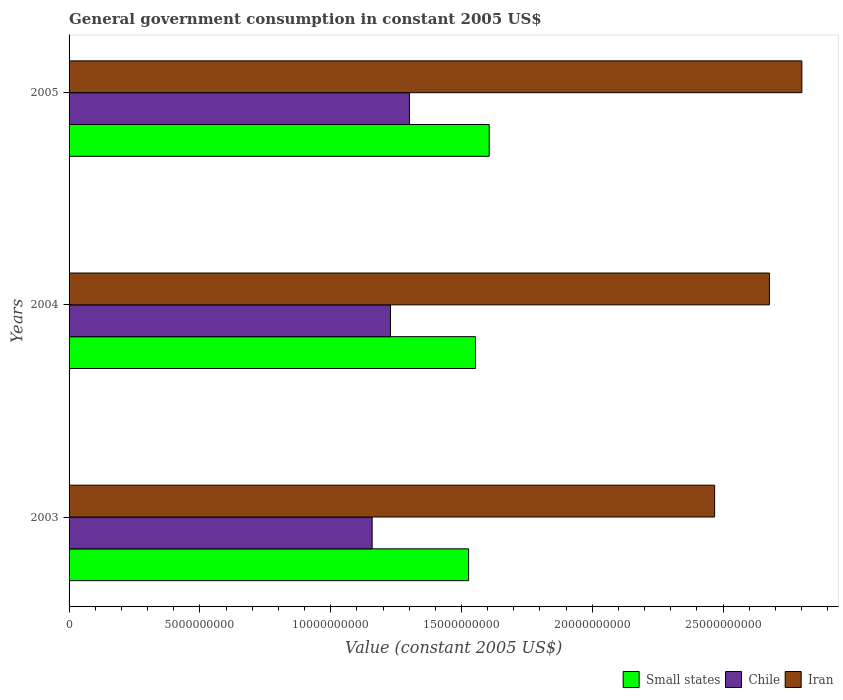How many different coloured bars are there?
Ensure brevity in your answer.  3. How many groups of bars are there?
Your answer should be very brief. 3. Are the number of bars per tick equal to the number of legend labels?
Provide a short and direct response. Yes. What is the label of the 2nd group of bars from the top?
Provide a short and direct response. 2004. In how many cases, is the number of bars for a given year not equal to the number of legend labels?
Your answer should be very brief. 0. What is the government conusmption in Iran in 2005?
Offer a very short reply. 2.80e+1. Across all years, what is the maximum government conusmption in Small states?
Your answer should be very brief. 1.61e+1. Across all years, what is the minimum government conusmption in Small states?
Your answer should be compact. 1.53e+1. In which year was the government conusmption in Iran maximum?
Ensure brevity in your answer.  2005. In which year was the government conusmption in Iran minimum?
Make the answer very short. 2003. What is the total government conusmption in Chile in the graph?
Provide a succinct answer. 3.69e+1. What is the difference between the government conusmption in Iran in 2004 and that in 2005?
Keep it short and to the point. -1.24e+09. What is the difference between the government conusmption in Chile in 2004 and the government conusmption in Iran in 2005?
Make the answer very short. -1.57e+1. What is the average government conusmption in Chile per year?
Ensure brevity in your answer.  1.23e+1. In the year 2005, what is the difference between the government conusmption in Iran and government conusmption in Small states?
Your answer should be very brief. 1.20e+1. In how many years, is the government conusmption in Iran greater than 3000000000 US$?
Offer a very short reply. 3. What is the ratio of the government conusmption in Chile in 2004 to that in 2005?
Your answer should be very brief. 0.94. What is the difference between the highest and the second highest government conusmption in Small states?
Your answer should be compact. 5.24e+08. What is the difference between the highest and the lowest government conusmption in Iran?
Keep it short and to the point. 3.33e+09. In how many years, is the government conusmption in Chile greater than the average government conusmption in Chile taken over all years?
Your answer should be compact. 1. Is the sum of the government conusmption in Iran in 2003 and 2005 greater than the maximum government conusmption in Chile across all years?
Your answer should be very brief. Yes. What does the 3rd bar from the top in 2005 represents?
Make the answer very short. Small states. What does the 2nd bar from the bottom in 2005 represents?
Your answer should be compact. Chile. How many bars are there?
Give a very brief answer. 9. How many years are there in the graph?
Provide a succinct answer. 3. Does the graph contain grids?
Provide a succinct answer. No. How are the legend labels stacked?
Provide a short and direct response. Horizontal. What is the title of the graph?
Make the answer very short. General government consumption in constant 2005 US$. What is the label or title of the X-axis?
Offer a terse response. Value (constant 2005 US$). What is the Value (constant 2005 US$) of Small states in 2003?
Give a very brief answer. 1.53e+1. What is the Value (constant 2005 US$) of Chile in 2003?
Your answer should be compact. 1.16e+1. What is the Value (constant 2005 US$) of Iran in 2003?
Provide a short and direct response. 2.47e+1. What is the Value (constant 2005 US$) of Small states in 2004?
Make the answer very short. 1.55e+1. What is the Value (constant 2005 US$) in Chile in 2004?
Provide a short and direct response. 1.23e+1. What is the Value (constant 2005 US$) in Iran in 2004?
Your response must be concise. 2.68e+1. What is the Value (constant 2005 US$) in Small states in 2005?
Ensure brevity in your answer.  1.61e+1. What is the Value (constant 2005 US$) of Chile in 2005?
Give a very brief answer. 1.30e+1. What is the Value (constant 2005 US$) in Iran in 2005?
Offer a terse response. 2.80e+1. Across all years, what is the maximum Value (constant 2005 US$) in Small states?
Keep it short and to the point. 1.61e+1. Across all years, what is the maximum Value (constant 2005 US$) in Chile?
Provide a succinct answer. 1.30e+1. Across all years, what is the maximum Value (constant 2005 US$) of Iran?
Keep it short and to the point. 2.80e+1. Across all years, what is the minimum Value (constant 2005 US$) of Small states?
Offer a terse response. 1.53e+1. Across all years, what is the minimum Value (constant 2005 US$) in Chile?
Keep it short and to the point. 1.16e+1. Across all years, what is the minimum Value (constant 2005 US$) of Iran?
Your answer should be very brief. 2.47e+1. What is the total Value (constant 2005 US$) in Small states in the graph?
Your answer should be compact. 4.69e+1. What is the total Value (constant 2005 US$) in Chile in the graph?
Offer a terse response. 3.69e+1. What is the total Value (constant 2005 US$) in Iran in the graph?
Your answer should be very brief. 7.95e+1. What is the difference between the Value (constant 2005 US$) of Small states in 2003 and that in 2004?
Your answer should be very brief. -2.64e+08. What is the difference between the Value (constant 2005 US$) in Chile in 2003 and that in 2004?
Offer a very short reply. -7.01e+08. What is the difference between the Value (constant 2005 US$) of Iran in 2003 and that in 2004?
Give a very brief answer. -2.09e+09. What is the difference between the Value (constant 2005 US$) in Small states in 2003 and that in 2005?
Offer a terse response. -7.88e+08. What is the difference between the Value (constant 2005 US$) of Chile in 2003 and that in 2005?
Your response must be concise. -1.43e+09. What is the difference between the Value (constant 2005 US$) in Iran in 2003 and that in 2005?
Offer a terse response. -3.33e+09. What is the difference between the Value (constant 2005 US$) in Small states in 2004 and that in 2005?
Offer a terse response. -5.24e+08. What is the difference between the Value (constant 2005 US$) of Chile in 2004 and that in 2005?
Your response must be concise. -7.25e+08. What is the difference between the Value (constant 2005 US$) of Iran in 2004 and that in 2005?
Make the answer very short. -1.24e+09. What is the difference between the Value (constant 2005 US$) of Small states in 2003 and the Value (constant 2005 US$) of Chile in 2004?
Provide a succinct answer. 2.99e+09. What is the difference between the Value (constant 2005 US$) of Small states in 2003 and the Value (constant 2005 US$) of Iran in 2004?
Make the answer very short. -1.15e+1. What is the difference between the Value (constant 2005 US$) of Chile in 2003 and the Value (constant 2005 US$) of Iran in 2004?
Your answer should be very brief. -1.52e+1. What is the difference between the Value (constant 2005 US$) in Small states in 2003 and the Value (constant 2005 US$) in Chile in 2005?
Offer a terse response. 2.26e+09. What is the difference between the Value (constant 2005 US$) in Small states in 2003 and the Value (constant 2005 US$) in Iran in 2005?
Your answer should be very brief. -1.27e+1. What is the difference between the Value (constant 2005 US$) in Chile in 2003 and the Value (constant 2005 US$) in Iran in 2005?
Give a very brief answer. -1.64e+1. What is the difference between the Value (constant 2005 US$) of Small states in 2004 and the Value (constant 2005 US$) of Chile in 2005?
Give a very brief answer. 2.52e+09. What is the difference between the Value (constant 2005 US$) in Small states in 2004 and the Value (constant 2005 US$) in Iran in 2005?
Offer a terse response. -1.25e+1. What is the difference between the Value (constant 2005 US$) of Chile in 2004 and the Value (constant 2005 US$) of Iran in 2005?
Ensure brevity in your answer.  -1.57e+1. What is the average Value (constant 2005 US$) of Small states per year?
Ensure brevity in your answer.  1.56e+1. What is the average Value (constant 2005 US$) in Chile per year?
Ensure brevity in your answer.  1.23e+1. What is the average Value (constant 2005 US$) in Iran per year?
Provide a succinct answer. 2.65e+1. In the year 2003, what is the difference between the Value (constant 2005 US$) in Small states and Value (constant 2005 US$) in Chile?
Offer a very short reply. 3.69e+09. In the year 2003, what is the difference between the Value (constant 2005 US$) of Small states and Value (constant 2005 US$) of Iran?
Keep it short and to the point. -9.40e+09. In the year 2003, what is the difference between the Value (constant 2005 US$) in Chile and Value (constant 2005 US$) in Iran?
Ensure brevity in your answer.  -1.31e+1. In the year 2004, what is the difference between the Value (constant 2005 US$) of Small states and Value (constant 2005 US$) of Chile?
Keep it short and to the point. 3.25e+09. In the year 2004, what is the difference between the Value (constant 2005 US$) of Small states and Value (constant 2005 US$) of Iran?
Keep it short and to the point. -1.12e+1. In the year 2004, what is the difference between the Value (constant 2005 US$) of Chile and Value (constant 2005 US$) of Iran?
Offer a very short reply. -1.45e+1. In the year 2005, what is the difference between the Value (constant 2005 US$) of Small states and Value (constant 2005 US$) of Chile?
Provide a short and direct response. 3.05e+09. In the year 2005, what is the difference between the Value (constant 2005 US$) of Small states and Value (constant 2005 US$) of Iran?
Your answer should be compact. -1.20e+1. In the year 2005, what is the difference between the Value (constant 2005 US$) of Chile and Value (constant 2005 US$) of Iran?
Offer a terse response. -1.50e+1. What is the ratio of the Value (constant 2005 US$) in Chile in 2003 to that in 2004?
Offer a very short reply. 0.94. What is the ratio of the Value (constant 2005 US$) in Iran in 2003 to that in 2004?
Offer a terse response. 0.92. What is the ratio of the Value (constant 2005 US$) of Small states in 2003 to that in 2005?
Your answer should be very brief. 0.95. What is the ratio of the Value (constant 2005 US$) in Chile in 2003 to that in 2005?
Ensure brevity in your answer.  0.89. What is the ratio of the Value (constant 2005 US$) of Iran in 2003 to that in 2005?
Give a very brief answer. 0.88. What is the ratio of the Value (constant 2005 US$) of Small states in 2004 to that in 2005?
Make the answer very short. 0.97. What is the ratio of the Value (constant 2005 US$) in Chile in 2004 to that in 2005?
Offer a terse response. 0.94. What is the ratio of the Value (constant 2005 US$) of Iran in 2004 to that in 2005?
Your response must be concise. 0.96. What is the difference between the highest and the second highest Value (constant 2005 US$) in Small states?
Your answer should be very brief. 5.24e+08. What is the difference between the highest and the second highest Value (constant 2005 US$) in Chile?
Your answer should be compact. 7.25e+08. What is the difference between the highest and the second highest Value (constant 2005 US$) in Iran?
Provide a succinct answer. 1.24e+09. What is the difference between the highest and the lowest Value (constant 2005 US$) of Small states?
Offer a very short reply. 7.88e+08. What is the difference between the highest and the lowest Value (constant 2005 US$) of Chile?
Your response must be concise. 1.43e+09. What is the difference between the highest and the lowest Value (constant 2005 US$) of Iran?
Give a very brief answer. 3.33e+09. 